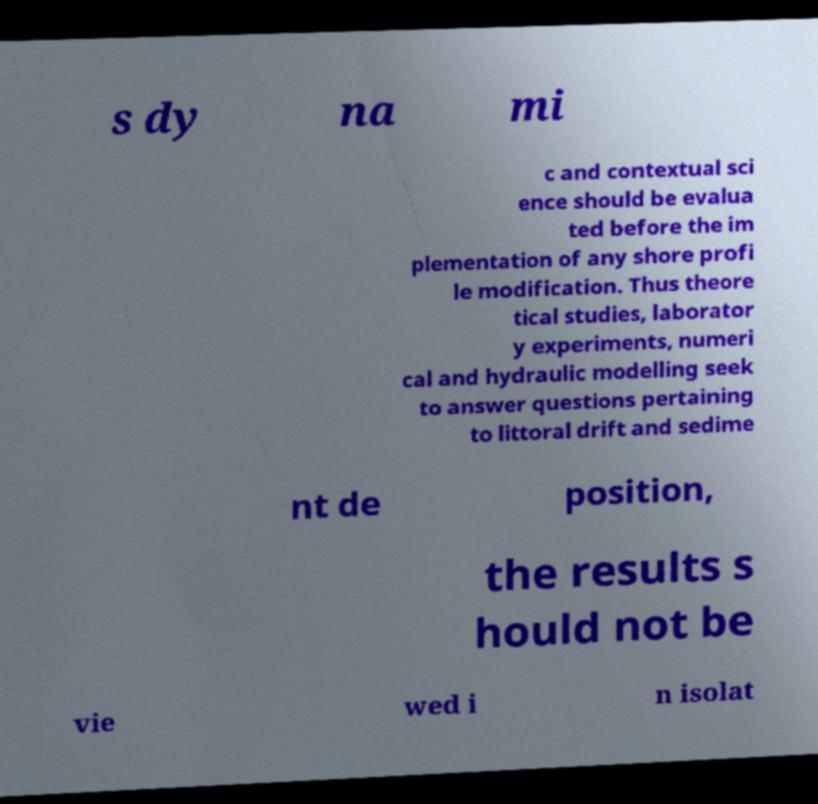I need the written content from this picture converted into text. Can you do that? s dy na mi c and contextual sci ence should be evalua ted before the im plementation of any shore profi le modification. Thus theore tical studies, laborator y experiments, numeri cal and hydraulic modelling seek to answer questions pertaining to littoral drift and sedime nt de position, the results s hould not be vie wed i n isolat 